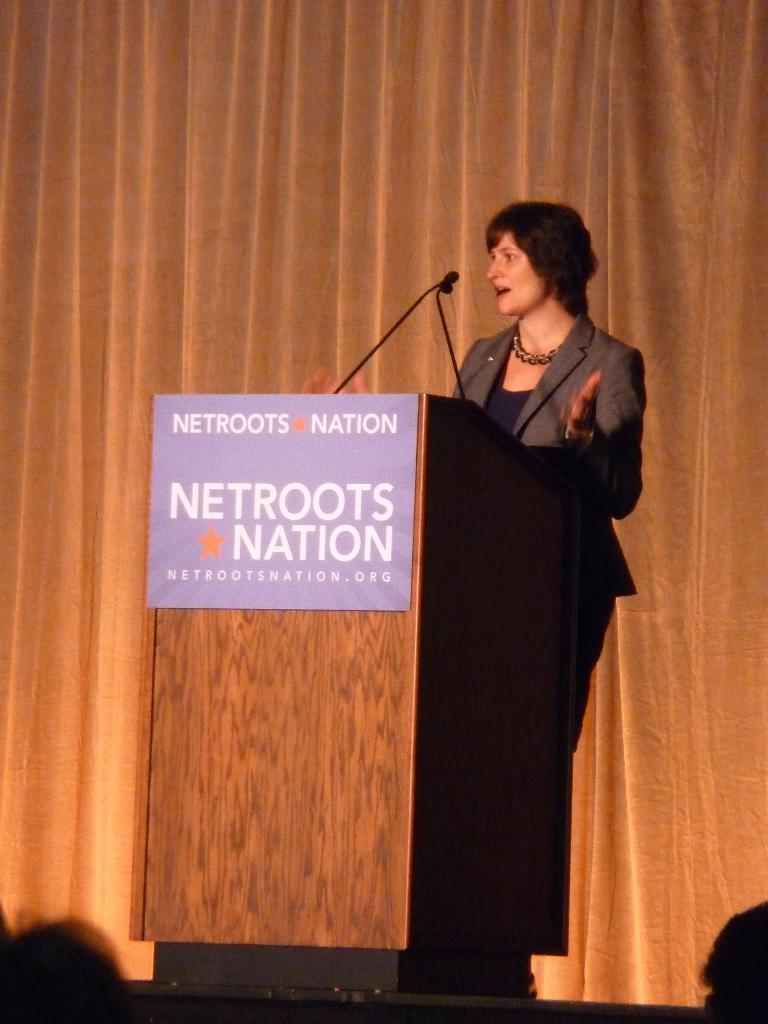<image>
Give a short and clear explanation of the subsequent image. the word netroots nation is on the podium 